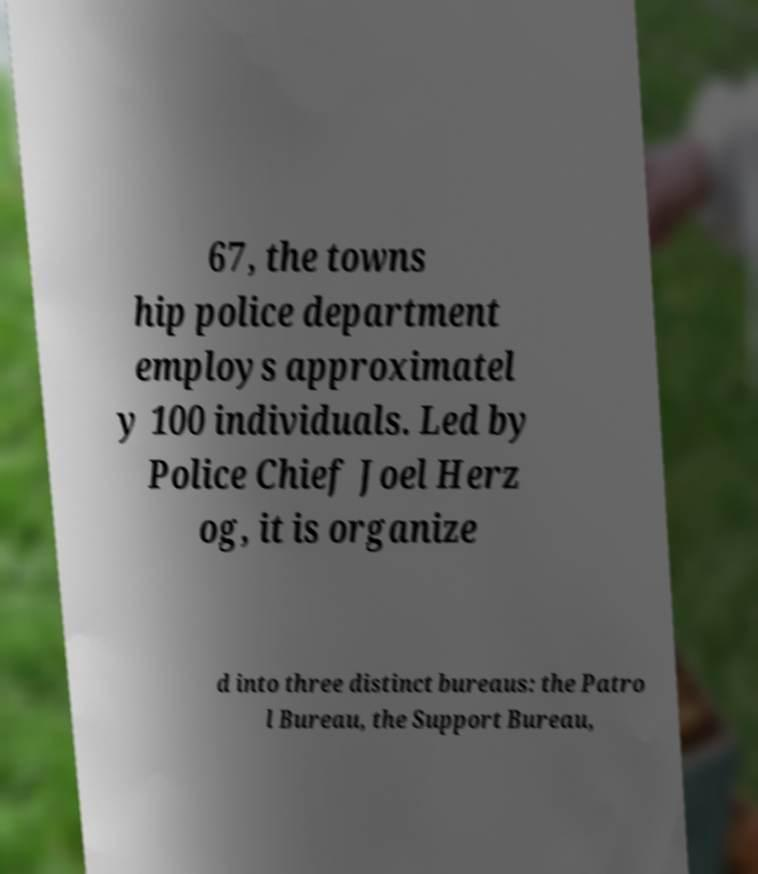Could you extract and type out the text from this image? 67, the towns hip police department employs approximatel y 100 individuals. Led by Police Chief Joel Herz og, it is organize d into three distinct bureaus: the Patro l Bureau, the Support Bureau, 